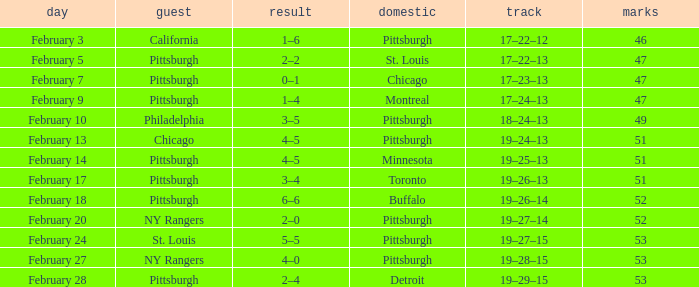Which Score has a Visitor of ny rangers, and a Record of 19–28–15? 4–0. 